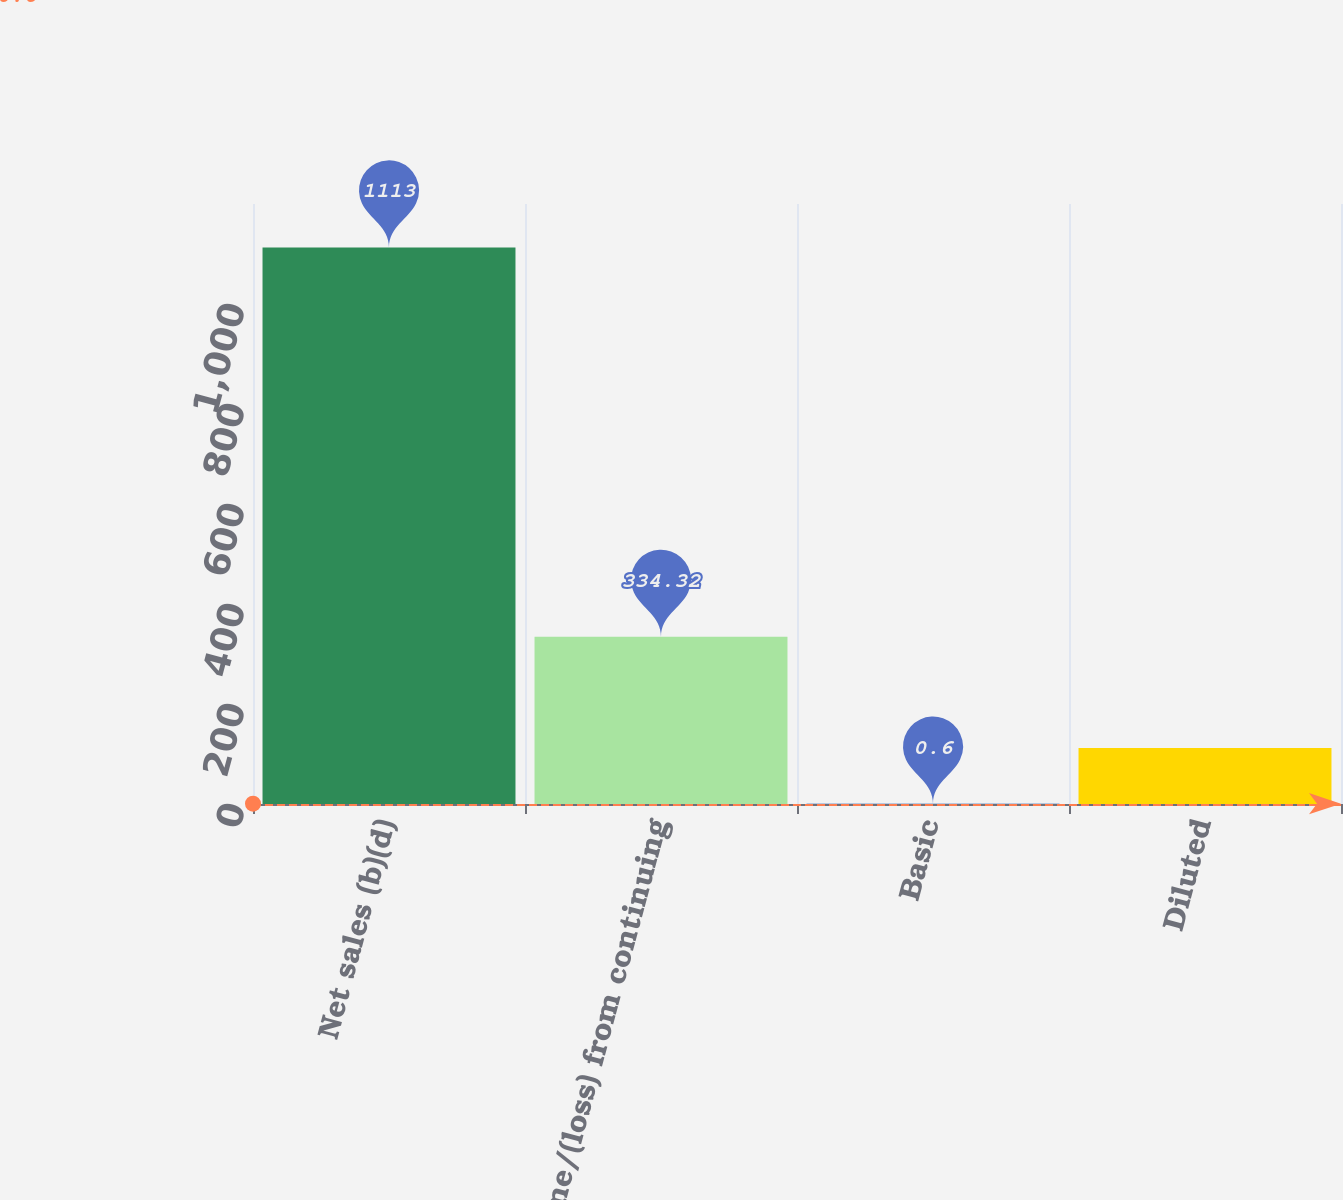<chart> <loc_0><loc_0><loc_500><loc_500><bar_chart><fcel>Net sales (b)(d)<fcel>Income/(loss) from continuing<fcel>Basic<fcel>Diluted<nl><fcel>1113<fcel>334.32<fcel>0.6<fcel>111.84<nl></chart> 